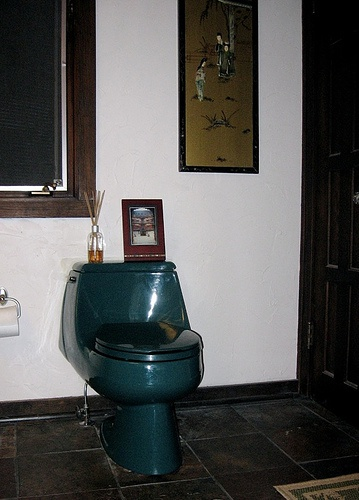Describe the objects in this image and their specific colors. I can see toilet in black, teal, gray, and darkblue tones and bottle in black, darkgray, lightgray, gray, and maroon tones in this image. 